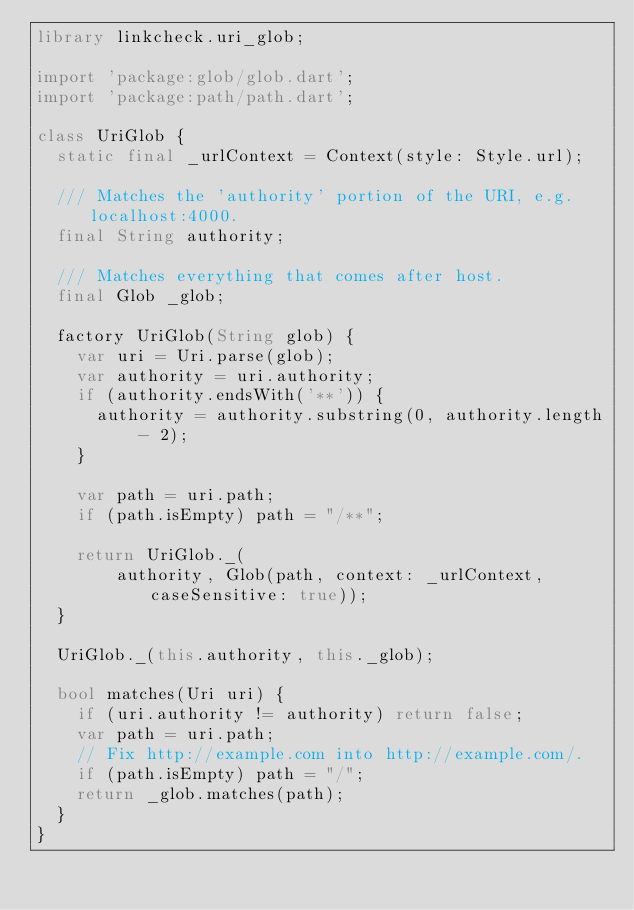<code> <loc_0><loc_0><loc_500><loc_500><_Dart_>library linkcheck.uri_glob;

import 'package:glob/glob.dart';
import 'package:path/path.dart';

class UriGlob {
  static final _urlContext = Context(style: Style.url);

  /// Matches the 'authority' portion of the URI, e.g. localhost:4000.
  final String authority;

  /// Matches everything that comes after host.
  final Glob _glob;

  factory UriGlob(String glob) {
    var uri = Uri.parse(glob);
    var authority = uri.authority;
    if (authority.endsWith('**')) {
      authority = authority.substring(0, authority.length - 2);
    }

    var path = uri.path;
    if (path.isEmpty) path = "/**";

    return UriGlob._(
        authority, Glob(path, context: _urlContext, caseSensitive: true));
  }

  UriGlob._(this.authority, this._glob);

  bool matches(Uri uri) {
    if (uri.authority != authority) return false;
    var path = uri.path;
    // Fix http://example.com into http://example.com/.
    if (path.isEmpty) path = "/";
    return _glob.matches(path);
  }
}
</code> 